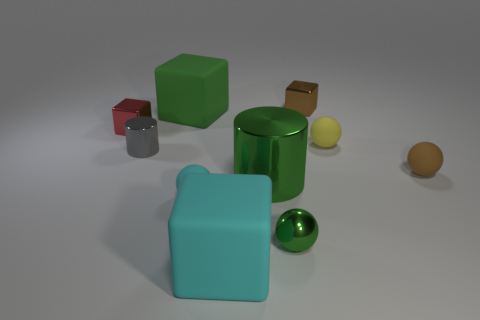Is there a tiny gray sphere that has the same material as the tiny green object? Upon close inspection of the image, it appears there is no tiny gray sphere present that mirrors the material characteristics of the tiny green object. 